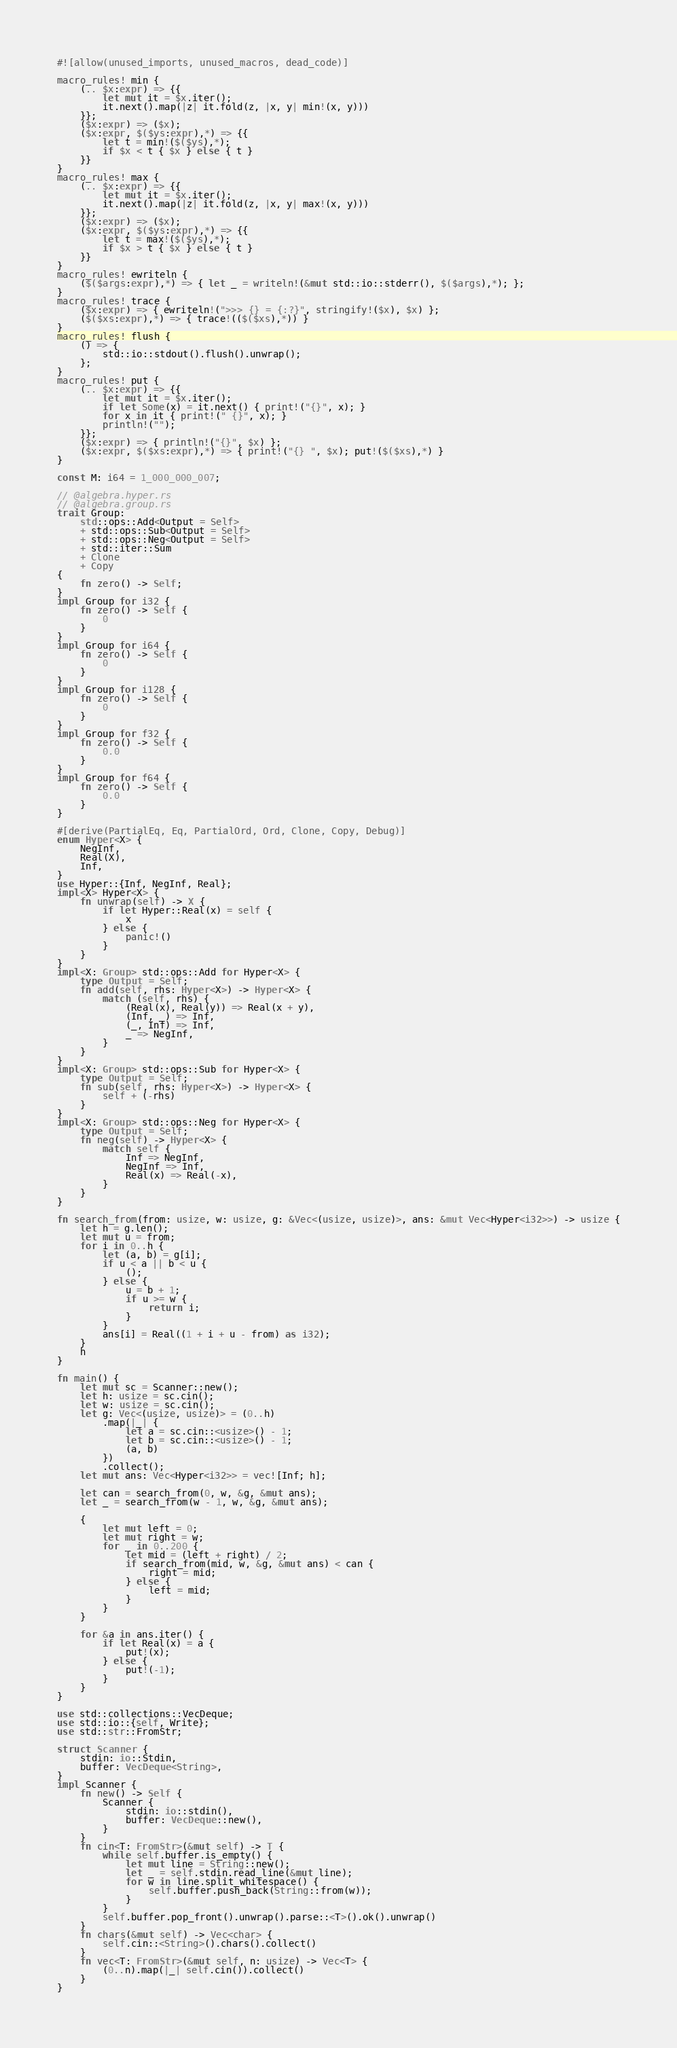<code> <loc_0><loc_0><loc_500><loc_500><_Rust_>#![allow(unused_imports, unused_macros, dead_code)]

macro_rules! min {
    (.. $x:expr) => {{
        let mut it = $x.iter();
        it.next().map(|z| it.fold(z, |x, y| min!(x, y)))
    }};
    ($x:expr) => ($x);
    ($x:expr, $($ys:expr),*) => {{
        let t = min!($($ys),*);
        if $x < t { $x } else { t }
    }}
}
macro_rules! max {
    (.. $x:expr) => {{
        let mut it = $x.iter();
        it.next().map(|z| it.fold(z, |x, y| max!(x, y)))
    }};
    ($x:expr) => ($x);
    ($x:expr, $($ys:expr),*) => {{
        let t = max!($($ys),*);
        if $x > t { $x } else { t }
    }}
}
macro_rules! ewriteln {
    ($($args:expr),*) => { let _ = writeln!(&mut std::io::stderr(), $($args),*); };
}
macro_rules! trace {
    ($x:expr) => { ewriteln!(">>> {} = {:?}", stringify!($x), $x) };
    ($($xs:expr),*) => { trace!(($($xs),*)) }
}
macro_rules! flush {
    () => {
        std::io::stdout().flush().unwrap();
    };
}
macro_rules! put {
    (.. $x:expr) => {{
        let mut it = $x.iter();
        if let Some(x) = it.next() { print!("{}", x); }
        for x in it { print!(" {}", x); }
        println!("");
    }};
    ($x:expr) => { println!("{}", $x) };
    ($x:expr, $($xs:expr),*) => { print!("{} ", $x); put!($($xs),*) }
}

const M: i64 = 1_000_000_007;

// @algebra.hyper.rs
// @algebra.group.rs
trait Group:
    std::ops::Add<Output = Self>
    + std::ops::Sub<Output = Self>
    + std::ops::Neg<Output = Self>
    + std::iter::Sum
    + Clone
    + Copy
{
    fn zero() -> Self;
}
impl Group for i32 {
    fn zero() -> Self {
        0
    }
}
impl Group for i64 {
    fn zero() -> Self {
        0
    }
}
impl Group for i128 {
    fn zero() -> Self {
        0
    }
}
impl Group for f32 {
    fn zero() -> Self {
        0.0
    }
}
impl Group for f64 {
    fn zero() -> Self {
        0.0
    }
}

#[derive(PartialEq, Eq, PartialOrd, Ord, Clone, Copy, Debug)]
enum Hyper<X> {
    NegInf,
    Real(X),
    Inf,
}
use Hyper::{Inf, NegInf, Real};
impl<X> Hyper<X> {
    fn unwrap(self) -> X {
        if let Hyper::Real(x) = self {
            x
        } else {
            panic!()
        }
    }
}
impl<X: Group> std::ops::Add for Hyper<X> {
    type Output = Self;
    fn add(self, rhs: Hyper<X>) -> Hyper<X> {
        match (self, rhs) {
            (Real(x), Real(y)) => Real(x + y),
            (Inf, _) => Inf,
            (_, Inf) => Inf,
            _ => NegInf,
        }
    }
}
impl<X: Group> std::ops::Sub for Hyper<X> {
    type Output = Self;
    fn sub(self, rhs: Hyper<X>) -> Hyper<X> {
        self + (-rhs)
    }
}
impl<X: Group> std::ops::Neg for Hyper<X> {
    type Output = Self;
    fn neg(self) -> Hyper<X> {
        match self {
            Inf => NegInf,
            NegInf => Inf,
            Real(x) => Real(-x),
        }
    }
}

fn search_from(from: usize, w: usize, g: &Vec<(usize, usize)>, ans: &mut Vec<Hyper<i32>>) -> usize {
    let h = g.len();
    let mut u = from;
    for i in 0..h {
        let (a, b) = g[i];
        if u < a || b < u {
            ();
        } else {
            u = b + 1;
            if u >= w {
                return i;
            }
        }
        ans[i] = Real((1 + i + u - from) as i32);
    }
    h
}

fn main() {
    let mut sc = Scanner::new();
    let h: usize = sc.cin();
    let w: usize = sc.cin();
    let g: Vec<(usize, usize)> = (0..h)
        .map(|_| {
            let a = sc.cin::<usize>() - 1;
            let b = sc.cin::<usize>() - 1;
            (a, b)
        })
        .collect();
    let mut ans: Vec<Hyper<i32>> = vec![Inf; h];

    let can = search_from(0, w, &g, &mut ans);
    let _ = search_from(w - 1, w, &g, &mut ans);

    {
        let mut left = 0;
        let mut right = w;
        for _ in 0..200 {
            let mid = (left + right) / 2;
            if search_from(mid, w, &g, &mut ans) < can {
                right = mid;
            } else {
                left = mid;
            }
        }
    }

    for &a in ans.iter() {
        if let Real(x) = a {
            put!(x);
        } else {
            put!(-1);
        }
    }
}

use std::collections::VecDeque;
use std::io::{self, Write};
use std::str::FromStr;

struct Scanner {
    stdin: io::Stdin,
    buffer: VecDeque<String>,
}
impl Scanner {
    fn new() -> Self {
        Scanner {
            stdin: io::stdin(),
            buffer: VecDeque::new(),
        }
    }
    fn cin<T: FromStr>(&mut self) -> T {
        while self.buffer.is_empty() {
            let mut line = String::new();
            let _ = self.stdin.read_line(&mut line);
            for w in line.split_whitespace() {
                self.buffer.push_back(String::from(w));
            }
        }
        self.buffer.pop_front().unwrap().parse::<T>().ok().unwrap()
    }
    fn chars(&mut self) -> Vec<char> {
        self.cin::<String>().chars().collect()
    }
    fn vec<T: FromStr>(&mut self, n: usize) -> Vec<T> {
        (0..n).map(|_| self.cin()).collect()
    }
}
</code> 